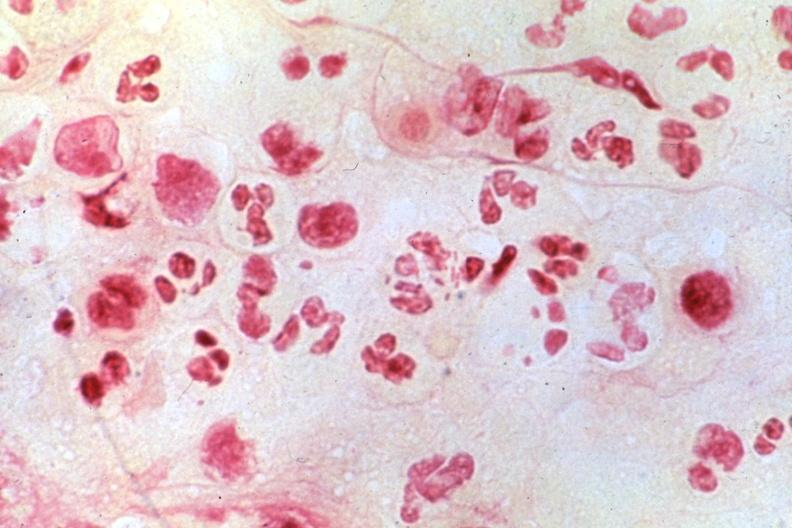s penis present?
Answer the question using a single word or phrase. Yes 